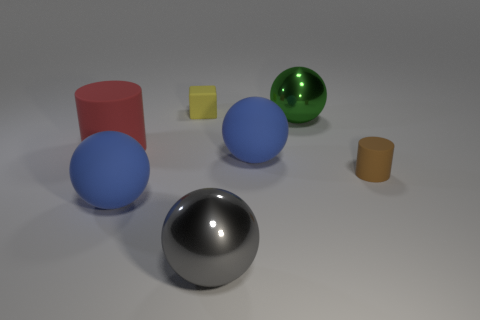Add 1 tiny yellow matte objects. How many objects exist? 8 Subtract all cylinders. How many objects are left? 5 Subtract 0 red spheres. How many objects are left? 7 Subtract all big green balls. Subtract all big gray metal balls. How many objects are left? 5 Add 2 large green metal balls. How many large green metal balls are left? 3 Add 5 small blue matte things. How many small blue matte things exist? 5 